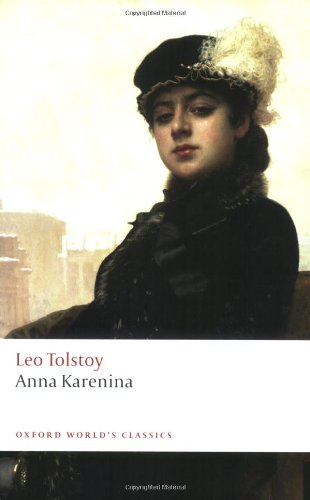Is this book related to Literature & Fiction? Yes, 'Anna Karenina' is indeed classified under Literature & Fiction, covering elements of human emotions and philosophical thoughts that haunt the realms of classical literature. 